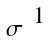Convert formula to latex. <formula><loc_0><loc_0><loc_500><loc_500>\begin{smallmatrix} & 1 \\ \sigma & \end{smallmatrix}</formula> 